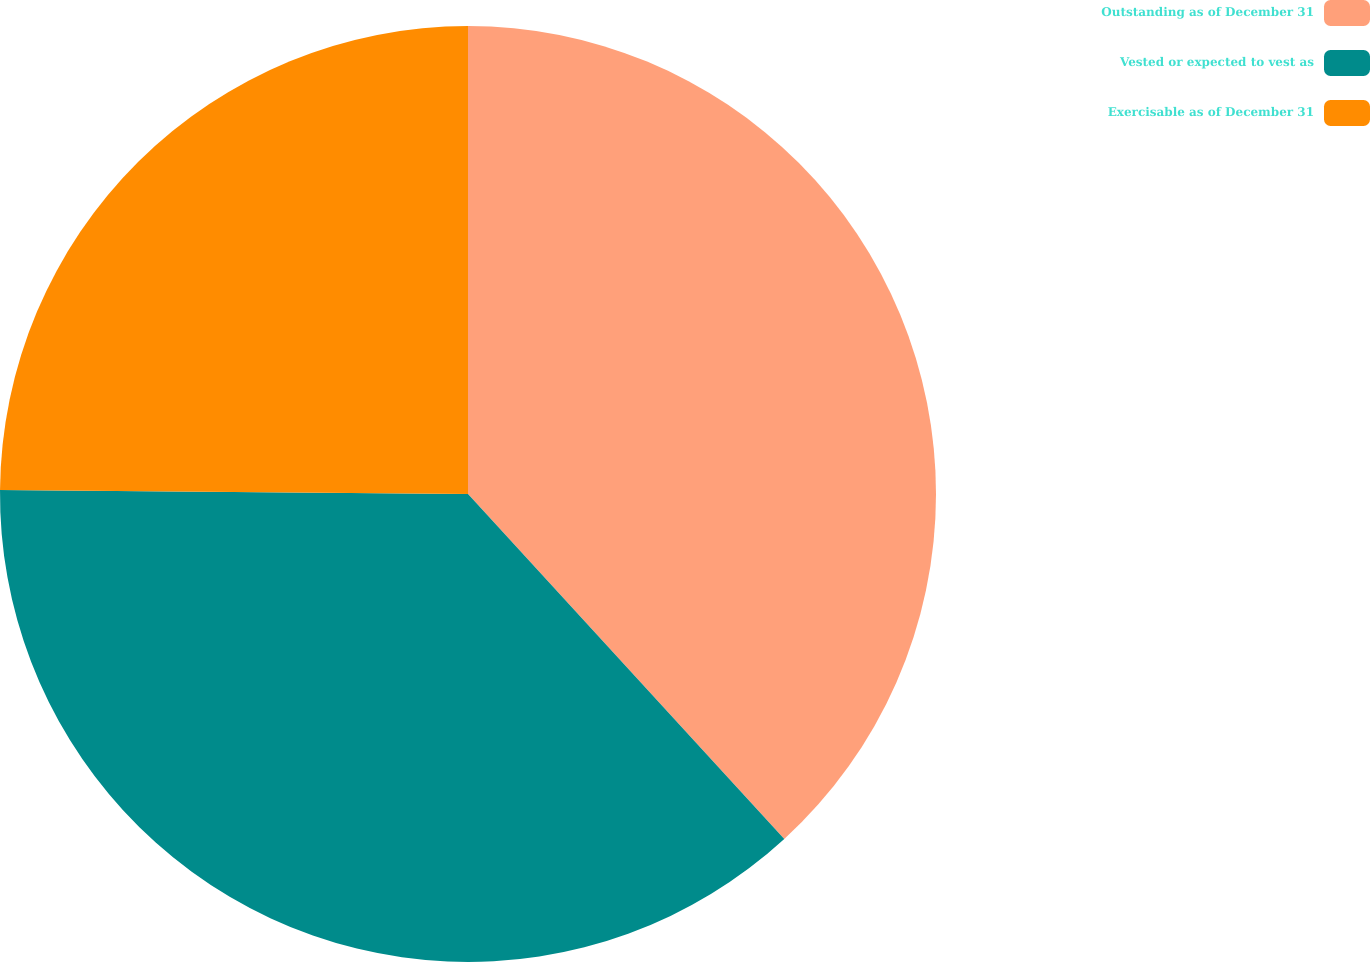<chart> <loc_0><loc_0><loc_500><loc_500><pie_chart><fcel>Outstanding as of December 31<fcel>Vested or expected to vest as<fcel>Exercisable as of December 31<nl><fcel>38.19%<fcel>36.95%<fcel>24.86%<nl></chart> 